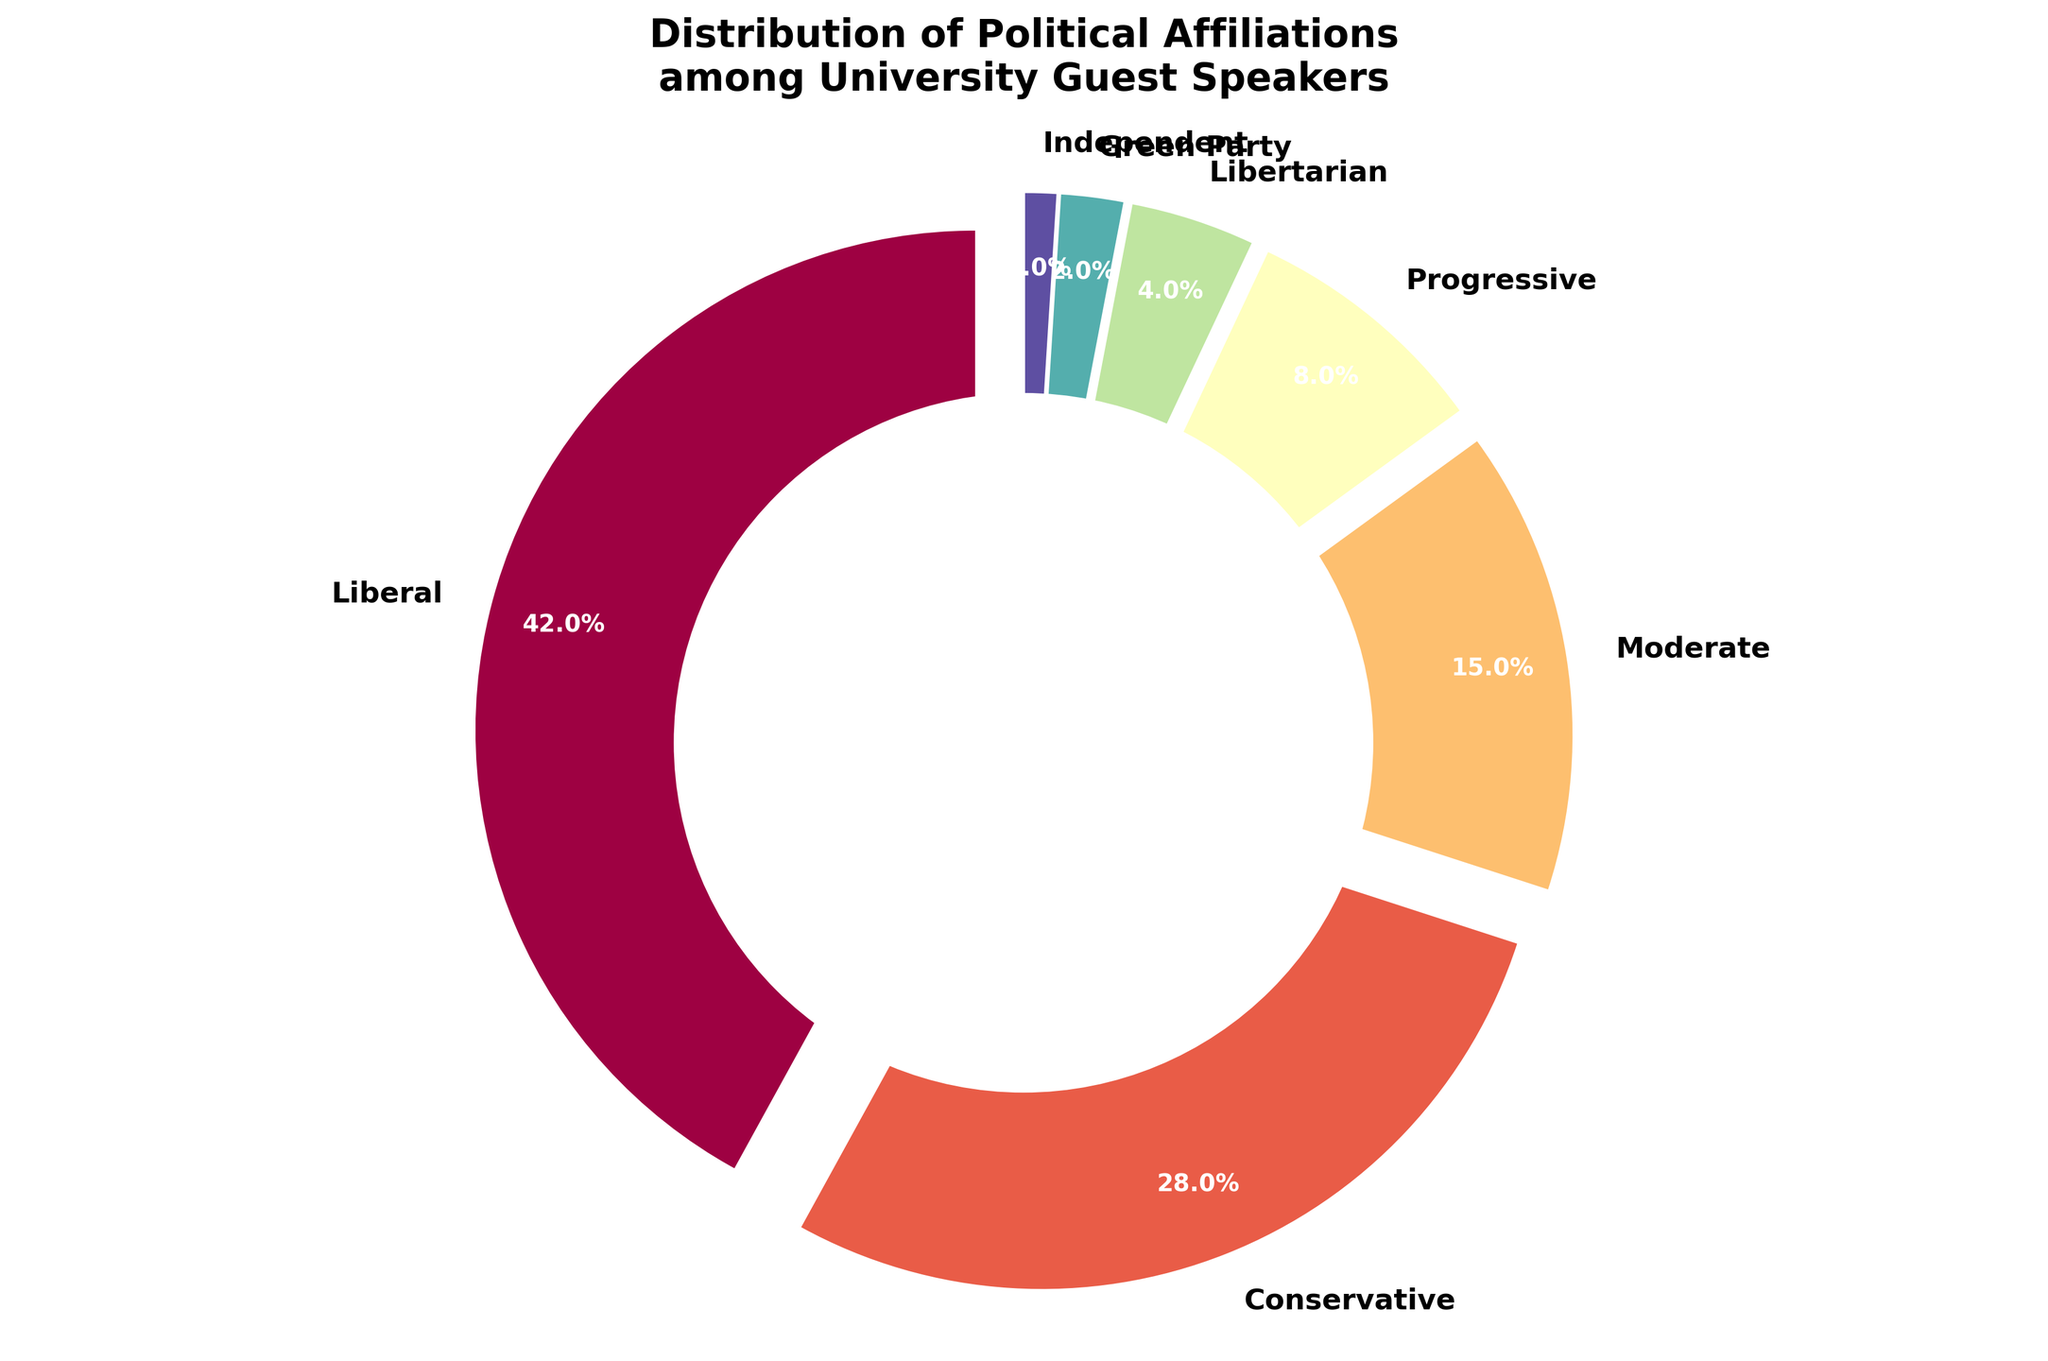What percentage of the guest speakers are either Liberal or Progressive? To find the percentage of guest speakers that are either Liberal or Progressive, you need to add the two percentages. Liberal speakers make up 42%, and Progressive speakers make up 8%. Adding these together, you get 42% + 8% = 50%.
Answer: 50% By how much do Liberal guest speakers outnumber Conservative guest speakers in percentage terms? To find out by how much Liberal guest speakers outnumber Conservative guest speakers, you subtract the percentage of Conservative speakers from that of Liberal speakers. Liberals have 42%, and Conservatives have 28%. So: 42% - 28% = 14%.
Answer: 14% Which political affiliation has the smallest representation among university guest speakers? The Green Party has the smallest representation among university guest speakers, which can be identified by observing the smallest segment in the pie chart and checking its label, which shows 2%.
Answer: Green Party What is the combined percentage of speakers with Moderate and Independent affiliations? To find the combined percentage of speakers with Moderate and Independent affiliations, you add the two percentages. Moderates make up 15%, and Independents make up 1%. Adding these together, you get 15% + 1% = 16%.
Answer: 16% Compare the percentage of guest speakers with Libertarian affiliation to those with Progressive affiliation. Which group has a higher percentage? In the pie chart, the Libertarian speakers represent 4% while Progressive speakers represent 8%. Since 8% is greater than 4%, Progressive speakers have a higher percentage than Libertarian speakers.
Answer: Progressive What is the difference between the percentage of guest speakers who are Liberal compared to the percentage of those who are Moderates? To find the difference between the percentage of Liberal guest speakers and Moderates, you subtract the Moderate percentage from the Liberal percentage. Liberals account for 42%, and Moderates account for 15%. So: 42% - 15% = 27%.
Answer: 27% Which two political affiliations combined make up exactly 10% of the guest speakers? To find which two political affiliations combined make up exactly 10%, you need to find two segments whose combined percentages equal 10%. Libertarians have 4% and the Green Party has 2%, totaling 6%. Independents have 1%, so you can pair them with Progressives who have 8%. Adding these: 8% + 2% = 10%.
Answer: Libertarian and Green Party 